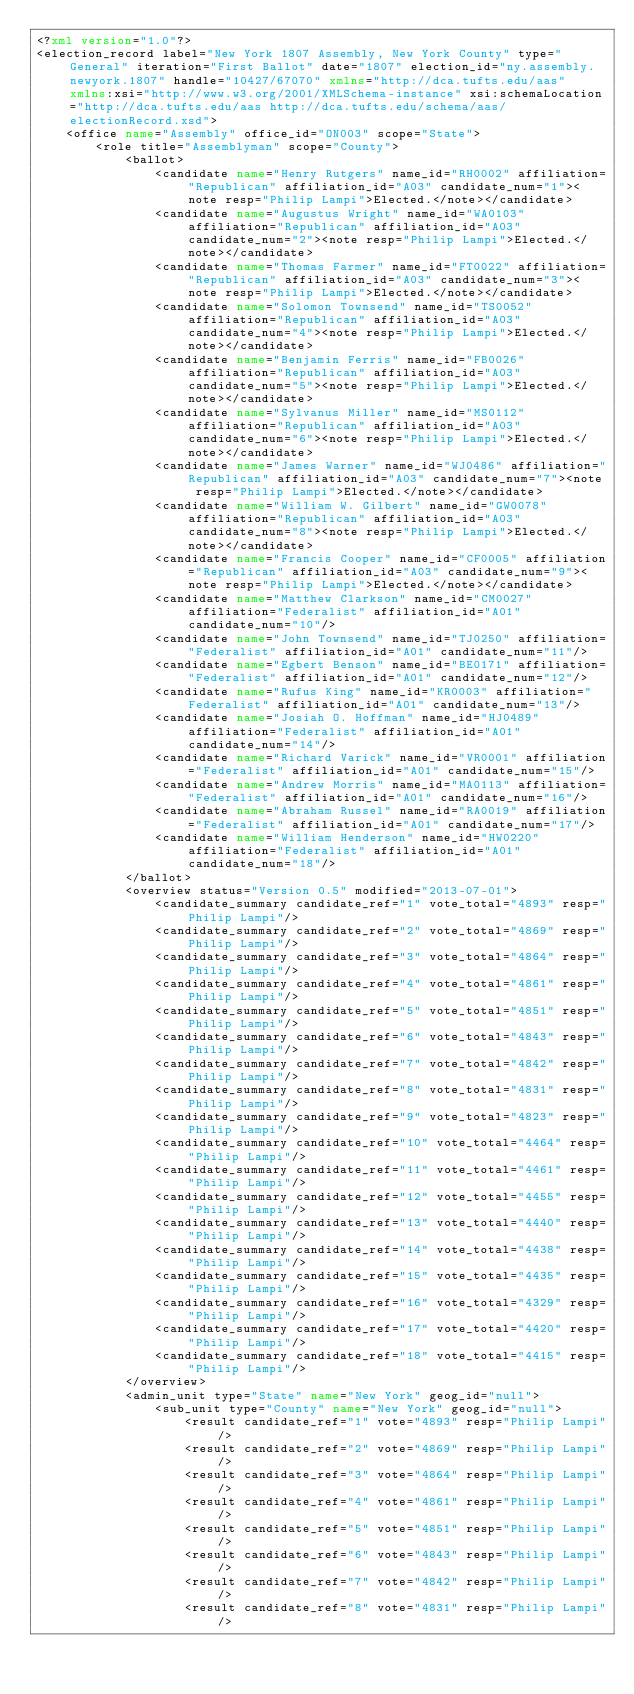<code> <loc_0><loc_0><loc_500><loc_500><_XML_><?xml version="1.0"?>
<election_record label="New York 1807 Assembly, New York County" type="General" iteration="First Ballot" date="1807" election_id="ny.assembly.newyork.1807" handle="10427/67070" xmlns="http://dca.tufts.edu/aas" xmlns:xsi="http://www.w3.org/2001/XMLSchema-instance" xsi:schemaLocation="http://dca.tufts.edu/aas http://dca.tufts.edu/schema/aas/electionRecord.xsd">
	<office name="Assembly" office_id="ON003" scope="State">
		<role title="Assemblyman" scope="County">
			<ballot>
				<candidate name="Henry Rutgers" name_id="RH0002" affiliation="Republican" affiliation_id="A03" candidate_num="1"><note resp="Philip Lampi">Elected.</note></candidate>
				<candidate name="Augustus Wright" name_id="WA0103" affiliation="Republican" affiliation_id="A03" candidate_num="2"><note resp="Philip Lampi">Elected.</note></candidate>
				<candidate name="Thomas Farmer" name_id="FT0022" affiliation="Republican" affiliation_id="A03" candidate_num="3"><note resp="Philip Lampi">Elected.</note></candidate>
				<candidate name="Solomon Townsend" name_id="TS0052" affiliation="Republican" affiliation_id="A03" candidate_num="4"><note resp="Philip Lampi">Elected.</note></candidate>
				<candidate name="Benjamin Ferris" name_id="FB0026" affiliation="Republican" affiliation_id="A03" candidate_num="5"><note resp="Philip Lampi">Elected.</note></candidate>
				<candidate name="Sylvanus Miller" name_id="MS0112" affiliation="Republican" affiliation_id="A03" candidate_num="6"><note resp="Philip Lampi">Elected.</note></candidate>
				<candidate name="James Warner" name_id="WJ0486" affiliation="Republican" affiliation_id="A03" candidate_num="7"><note resp="Philip Lampi">Elected.</note></candidate>
				<candidate name="William W. Gilbert" name_id="GW0078" affiliation="Republican" affiliation_id="A03" candidate_num="8"><note resp="Philip Lampi">Elected.</note></candidate>
				<candidate name="Francis Cooper" name_id="CF0005" affiliation="Republican" affiliation_id="A03" candidate_num="9"><note resp="Philip Lampi">Elected.</note></candidate>
				<candidate name="Matthew Clarkson" name_id="CM0027" affiliation="Federalist" affiliation_id="A01" candidate_num="10"/>
				<candidate name="John Townsend" name_id="TJ0250" affiliation="Federalist" affiliation_id="A01" candidate_num="11"/>
				<candidate name="Egbert Benson" name_id="BE0171" affiliation="Federalist" affiliation_id="A01" candidate_num="12"/>
				<candidate name="Rufus King" name_id="KR0003" affiliation="Federalist" affiliation_id="A01" candidate_num="13"/>
				<candidate name="Josiah O. Hoffman" name_id="HJ0489" affiliation="Federalist" affiliation_id="A01" candidate_num="14"/>
				<candidate name="Richard Varick" name_id="VR0001" affiliation="Federalist" affiliation_id="A01" candidate_num="15"/>
				<candidate name="Andrew Morris" name_id="MA0113" affiliation="Federalist" affiliation_id="A01" candidate_num="16"/>
				<candidate name="Abraham Russel" name_id="RA0019" affiliation="Federalist" affiliation_id="A01" candidate_num="17"/>
				<candidate name="William Henderson" name_id="HW0220" affiliation="Federalist" affiliation_id="A01" candidate_num="18"/>
			</ballot>
			<overview status="Version 0.5" modified="2013-07-01">
				<candidate_summary candidate_ref="1" vote_total="4893" resp="Philip Lampi"/>
				<candidate_summary candidate_ref="2" vote_total="4869" resp="Philip Lampi"/>
				<candidate_summary candidate_ref="3" vote_total="4864" resp="Philip Lampi"/>
				<candidate_summary candidate_ref="4" vote_total="4861" resp="Philip Lampi"/>
				<candidate_summary candidate_ref="5" vote_total="4851" resp="Philip Lampi"/>
				<candidate_summary candidate_ref="6" vote_total="4843" resp="Philip Lampi"/>
				<candidate_summary candidate_ref="7" vote_total="4842" resp="Philip Lampi"/>
				<candidate_summary candidate_ref="8" vote_total="4831" resp="Philip Lampi"/>
				<candidate_summary candidate_ref="9" vote_total="4823" resp="Philip Lampi"/>
				<candidate_summary candidate_ref="10" vote_total="4464" resp="Philip Lampi"/>
				<candidate_summary candidate_ref="11" vote_total="4461" resp="Philip Lampi"/>
				<candidate_summary candidate_ref="12" vote_total="4455" resp="Philip Lampi"/>
				<candidate_summary candidate_ref="13" vote_total="4440" resp="Philip Lampi"/>
				<candidate_summary candidate_ref="14" vote_total="4438" resp="Philip Lampi"/>
				<candidate_summary candidate_ref="15" vote_total="4435" resp="Philip Lampi"/>
				<candidate_summary candidate_ref="16" vote_total="4329" resp="Philip Lampi"/>
				<candidate_summary candidate_ref="17" vote_total="4420" resp="Philip Lampi"/>
				<candidate_summary candidate_ref="18" vote_total="4415" resp="Philip Lampi"/>
			</overview>
			<admin_unit type="State" name="New York" geog_id="null">
				<sub_unit type="County" name="New York" geog_id="null">
					<result candidate_ref="1" vote="4893" resp="Philip Lampi"/>
					<result candidate_ref="2" vote="4869" resp="Philip Lampi"/>
					<result candidate_ref="3" vote="4864" resp="Philip Lampi"/>
					<result candidate_ref="4" vote="4861" resp="Philip Lampi"/>
					<result candidate_ref="5" vote="4851" resp="Philip Lampi"/>
					<result candidate_ref="6" vote="4843" resp="Philip Lampi"/>
					<result candidate_ref="7" vote="4842" resp="Philip Lampi"/>
					<result candidate_ref="8" vote="4831" resp="Philip Lampi"/></code> 